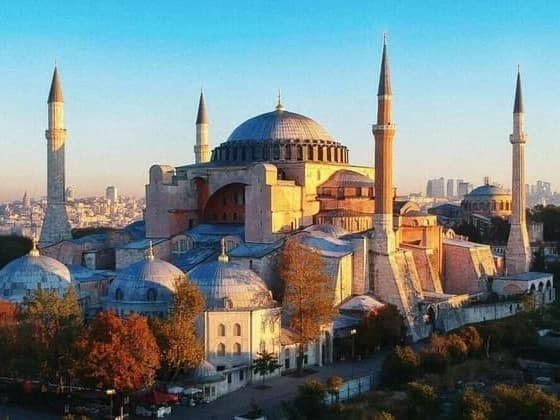Imagine how a pigeon might view its day while perched on one of the domes of this structure. As a pigeon perched atop the grand dome of the Hagia Sophia, the day begins with the first light of dawn painting the sky in hues of pink and orange. Stretching its wings, the pigeon surveys the bustling city of Istanbul from its lofty vantage point. The distant sounds of the city waking up, the calls of street vendors, and the rumble of traffic become a soft, distant hum, a backdrop to the serene, elevated perch. Gazing down, the pigeon sees the intricate details of the structure's mosaics and stonework, its keen eyes picking up patterns unnoticed by human visitors. The sun's warmth spreads across the dome, a perfect spot for basking. Throughout the day, it watches tourists and locals, children pointing excitedly and photographers trying to capture the perfect shot. Occasionally, it takes flight, circling above, blending with flocks of other city birds, before finding another peaceful spot on one of the minarets to rest. As evening falls, the pigeon’s perch becomes a quiet, reflective place, watching the setting sun bathe the Hagia Sophia in an ethereal glow, a moment of tranquility before night cloaks the city. Compose a poem inspired by the beauty and history of Hagia Sophia. Beneath the domes that touch the sky,
Where whispers of history softly lie,
Stands Hagia Sophia, grand and proud,
In its shadows, tales are loud.

Byzantine splendor in each stone laid,
Ottoman grace in minarets displayed,
A dance of cultures, time's embrace,
A sacred space in every case.

Sunlight pours through windows high,
Into the dome, where dreams can fly,
Golden mosaics, stories told,
In their glow, hearts unfold.

Byzantine chants, an echo fades,
Ottoman calls through marble colonnades,
Silent now, yet spirits see,
The unity in diversity.

Oh, Hagia Sophia, keeper of time,
Your beauty transcends, truly sublime,
A beacon of faith, a historical gem,
Eternal in Istanbul's diadem. Reflect on how Hagia Sophia's multiple roles as a church, mosque, and museum contribute to its significance. Hagia Sophia's journey through various roles as a church, mosque, and now a museum adds profound layers to its significance. Initially constructed as a grand cathedral, it represented the pinnacle of Byzantine architectural and religious devotion. Its transformation into a mosque after the Ottoman conquest symbolized the interweaving of cultures and the region's shift in spiritual dynamics, exemplifying religious coexistence over centuries. As a museum today, it stands as a beacon of cultural heritage and historical continuity, reflecting humanity's collective past. This layered history encapsulated in one monumental structure makes the Hagia Sophia a unique symbol of unity, resilience, and the enduring passage of time, bridging diverse cultural and historical narratives into a singular, revered landmark. If one could hear the walls of Hagia Sophia speak, what stories might they tell about the people who built and used it? If the walls of Hagia Sophia could speak, they would tell tales of emperors and architects dreaming of the sky, of countless artisans painstakingly laying each mosaic tile. They would recount the grandeur of Justinian I proclaiming 'Solomon, I have surpassed thee!' upon its completion. Time would bring whispers of the faithful Byzantines, their prayers intertwined with the divine echoes of sacred hymns. The conquest by Mehmet the Conqueror would add a new layer of stories, as Ottoman craftsmen gracefully infused their culture, adding minarets like exclamation points to history. The walls would narrate the serene call to prayer cascading through the ages, the silent, respectful tread of visitors from distant lands. Stories of resilience through earthquakes, preservation against the ravages of time, and a transformation into a museum, welcoming all. These walls have felt the pulse of every era, bearing witness to human ingenuity, faith, and the ceaseless march of history. 